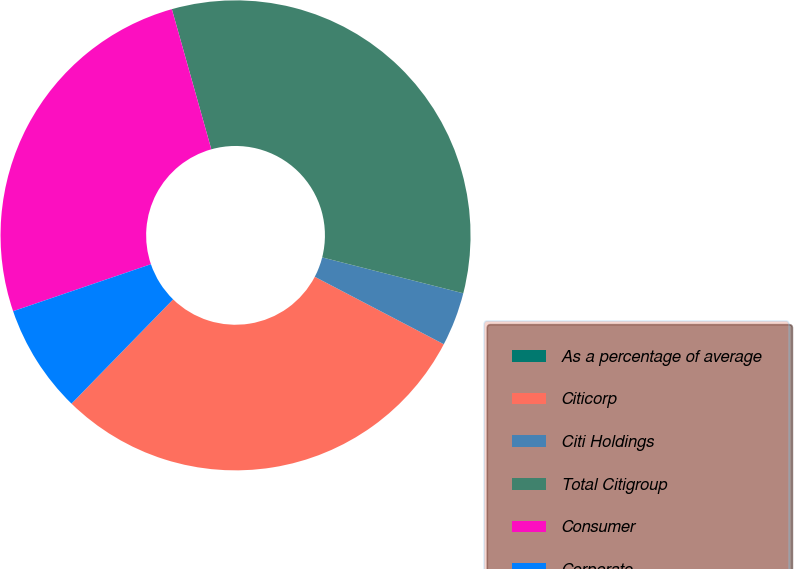<chart> <loc_0><loc_0><loc_500><loc_500><pie_chart><fcel>As a percentage of average<fcel>Citicorp<fcel>Citi Holdings<fcel>Total Citigroup<fcel>Consumer<fcel>Corporate<nl><fcel>0.0%<fcel>29.63%<fcel>3.7%<fcel>33.33%<fcel>25.86%<fcel>7.47%<nl></chart> 